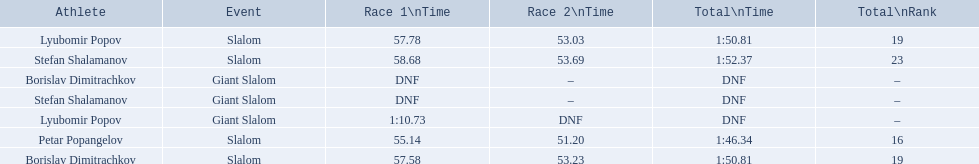What are all the competitions lyubomir popov competed in? Lyubomir Popov, Lyubomir Popov. Of those, which were giant slalom races? Giant Slalom. What was his time in race 1? 1:10.73. 